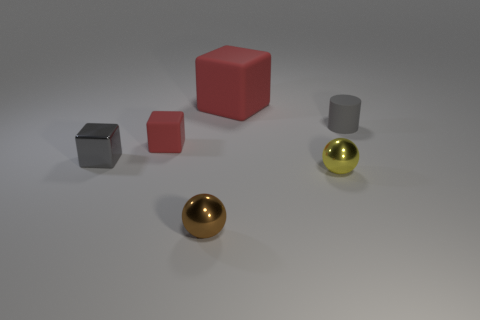What number of small gray cubes are to the right of the matte block in front of the small rubber cylinder?
Your response must be concise. 0. What number of things are gray objects to the right of the large matte cube or brown shiny cubes?
Keep it short and to the point. 1. How many big red things are made of the same material as the yellow thing?
Your response must be concise. 0. What is the shape of the small object that is the same color as the small cylinder?
Keep it short and to the point. Cube. Are there an equal number of balls to the right of the tiny gray matte thing and blue cubes?
Your answer should be compact. Yes. What size is the rubber cube behind the small gray cylinder?
Make the answer very short. Large. What number of tiny objects are either metal spheres or gray metal cubes?
Keep it short and to the point. 3. What color is the other big thing that is the same shape as the gray metallic thing?
Give a very brief answer. Red. Does the gray cylinder have the same size as the yellow metal sphere?
Offer a terse response. Yes. How many things are either cubes or small spheres that are to the right of the large matte object?
Offer a very short reply. 4. 